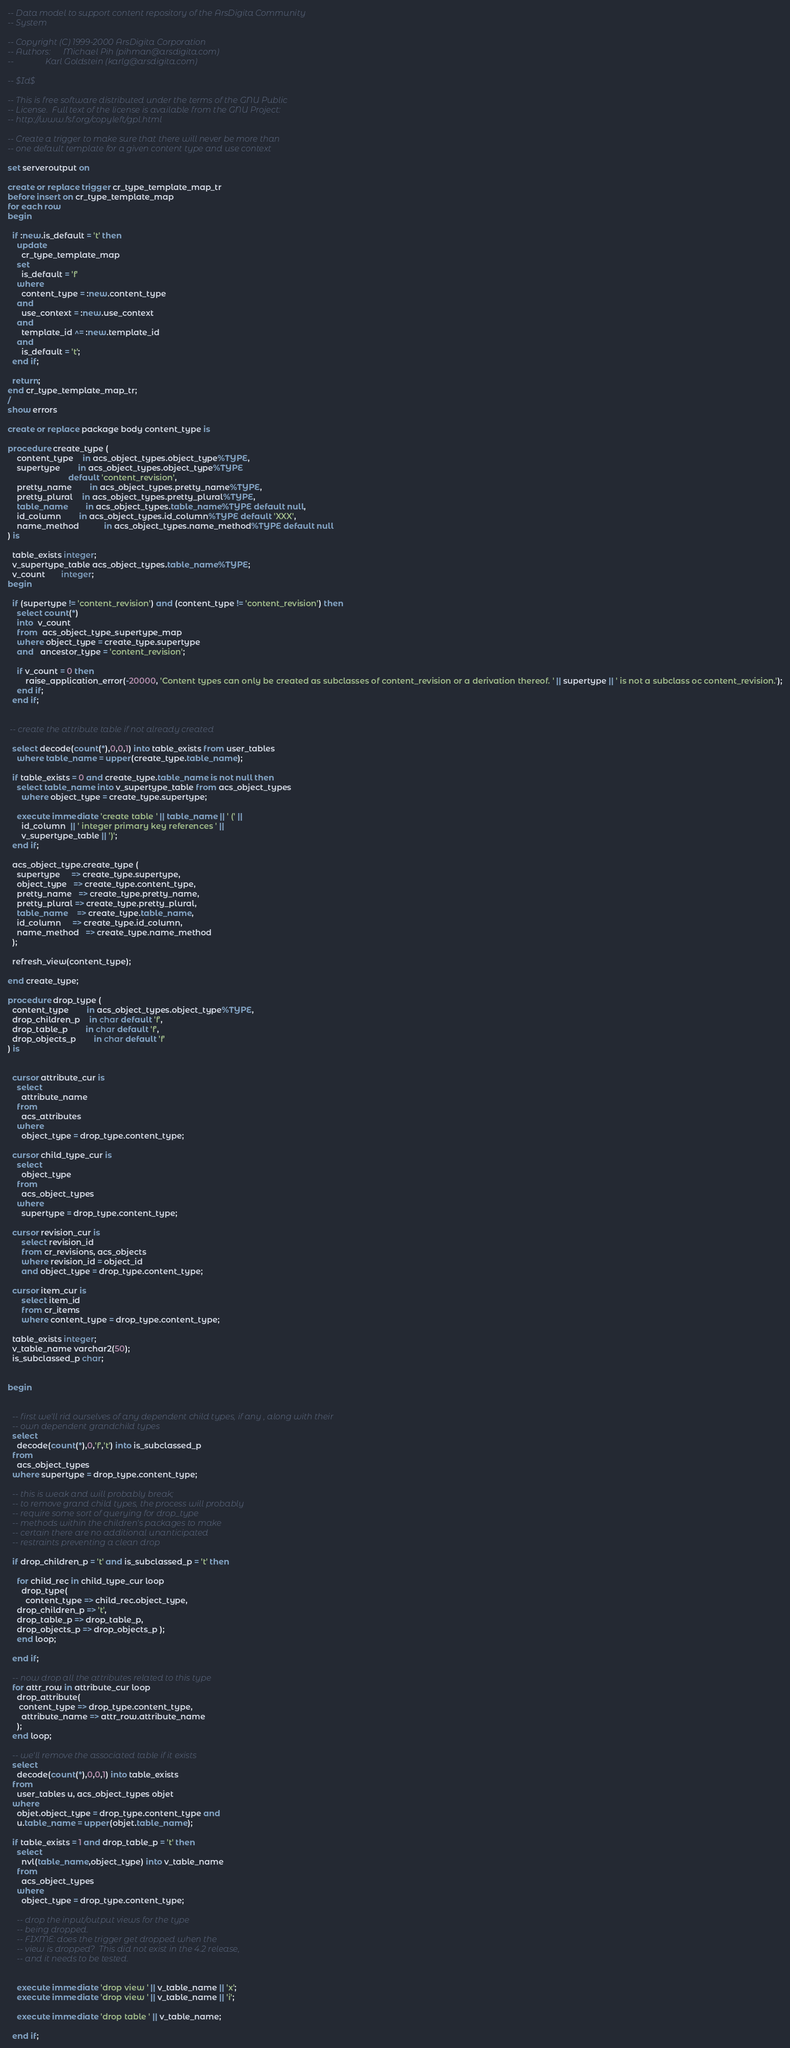<code> <loc_0><loc_0><loc_500><loc_500><_SQL_>-- Data model to support content repository of the ArsDigita Community
-- System

-- Copyright (C) 1999-2000 ArsDigita Corporation
-- Authors:      Michael Pih (pihman@arsdigita.com)
--               Karl Goldstein (karlg@arsdigita.com)

-- $Id$

-- This is free software distributed under the terms of the GNU Public
-- License.  Full text of the license is available from the GNU Project:
-- http://www.fsf.org/copyleft/gpl.html

-- Create a trigger to make sure that there will never be more than
-- one default template for a given content type and use context

set serveroutput on

create or replace trigger cr_type_template_map_tr
before insert on cr_type_template_map 
for each row
begin

  if :new.is_default = 't' then
    update
      cr_type_template_map
    set
      is_default = 'f'
    where
      content_type = :new.content_type
    and
      use_context = :new.use_context
    and 
      template_id ^= :new.template_id
    and
      is_default = 't';
  end if;

  return;
end cr_type_template_map_tr;
/
show errors

create or replace package body content_type is

procedure create_type (
    content_type	in acs_object_types.object_type%TYPE,
    supertype		in acs_object_types.object_type%TYPE 
                           default 'content_revision',
    pretty_name		in acs_object_types.pretty_name%TYPE,
    pretty_plural	in acs_object_types.pretty_plural%TYPE,
    table_name		in acs_object_types.table_name%TYPE default null,
    id_column		in acs_object_types.id_column%TYPE default 'XXX',
    name_method           in acs_object_types.name_method%TYPE default null
) is

  table_exists integer;
  v_supertype_table acs_object_types.table_name%TYPE;
  v_count       integer;
begin

  if (supertype != 'content_revision') and (content_type != 'content_revision') then
    select count(*)
    into  v_count
    from  acs_object_type_supertype_map
    where object_type = create_type.supertype
    and   ancestor_type = 'content_revision';

    if v_count = 0 then
        raise_application_error(-20000, 'Content types can only be created as subclasses of content_revision or a derivation thereof. ' || supertype || ' is not a subclass oc content_revision.');
    end if;
  end if;


 -- create the attribute table if not already created

  select decode(count(*),0,0,1) into table_exists from user_tables 
    where table_name = upper(create_type.table_name);

  if table_exists = 0 and create_type.table_name is not null then
    select table_name into v_supertype_table from acs_object_types
      where object_type = create_type.supertype;

    execute immediate 'create table ' || table_name || ' (' ||
      id_column  || ' integer primary key references ' || 
      v_supertype_table || ')';
  end if;

  acs_object_type.create_type (
    supertype     => create_type.supertype,
    object_type   => create_type.content_type,
    pretty_name   => create_type.pretty_name,
    pretty_plural => create_type.pretty_plural,
    table_name    => create_type.table_name,
    id_column     => create_type.id_column,
    name_method   => create_type.name_method
  );

  refresh_view(content_type);

end create_type;

procedure drop_type (
  content_type		in acs_object_types.object_type%TYPE,
  drop_children_p	in char default 'f',
  drop_table_p		in char default 'f',
  drop_objects_p		in char default 'f'
) is


  cursor attribute_cur is
    select
      attribute_name
    from
      acs_attributes
    where
      object_type = drop_type.content_type;

  cursor child_type_cur is 
    select 
      object_type
    from 
      acs_object_types
    where
      supertype = drop_type.content_type;
 
  cursor revision_cur is
      select revision_id 
      from cr_revisions, acs_objects
      where revision_id = object_id
      and object_type = drop_type.content_type;

  cursor item_cur is 
      select item_id 
      from cr_items
      where content_type = drop_type.content_type;
   
  table_exists integer;
  v_table_name varchar2(50);
  is_subclassed_p char;

 
begin


  -- first we'll rid ourselves of any dependent child types, if any , along with their
  -- own dependent grandchild types
  select 
    decode(count(*),0,'f','t') into is_subclassed_p 
  from 
    acs_object_types 
  where supertype = drop_type.content_type;

  -- this is weak and will probably break;
  -- to remove grand child types, the process will probably
  -- require some sort of querying for drop_type 
  -- methods within the children's packages to make
  -- certain there are no additional unanticipated
  -- restraints preventing a clean drop

  if drop_children_p = 't' and is_subclassed_p = 't' then

    for child_rec in child_type_cur loop
      drop_type( 
        content_type => child_rec.object_type,
	drop_children_p => 't',
	drop_table_p => drop_table_p,
	drop_objects_p => drop_objects_p );
    end loop;

  end if;

  -- now drop all the attributes related to this type
  for attr_row in attribute_cur loop
    drop_attribute(
     content_type => drop_type.content_type,
      attribute_name => attr_row.attribute_name
    );
  end loop;

  -- we'll remove the associated table if it exists
  select 
    decode(count(*),0,0,1) into table_exists 
  from 
    user_tables u, acs_object_types objet
  where 
    objet.object_type = drop_type.content_type and
    u.table_name = upper(objet.table_name);

  if table_exists = 1 and drop_table_p = 't' then
    select 
      nvl(table_name,object_type) into v_table_name 
    from 
      acs_object_types 
    where
      object_type = drop_type.content_type;

    -- drop the input/output views for the type
    -- being dropped.
    -- FIXME: does the trigger get dropped when the 
    -- view is dropped?  This did not exist in the 4.2 release,
    -- and it needs to be tested.

       
    execute immediate 'drop view ' || v_table_name || 'x';
    execute immediate 'drop view ' || v_table_name || 'i';

    execute immediate 'drop table ' || v_table_name;

  end if;
</code> 